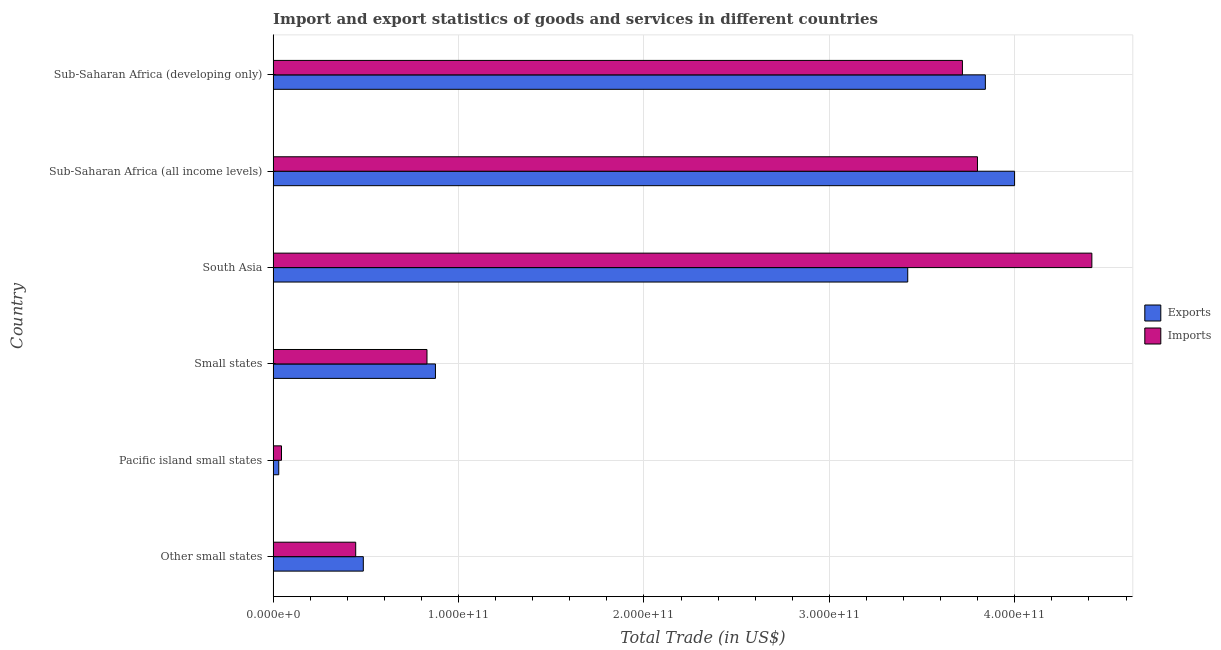How many different coloured bars are there?
Offer a very short reply. 2. How many groups of bars are there?
Make the answer very short. 6. Are the number of bars on each tick of the Y-axis equal?
Keep it short and to the point. Yes. How many bars are there on the 3rd tick from the top?
Your answer should be very brief. 2. How many bars are there on the 6th tick from the bottom?
Make the answer very short. 2. What is the label of the 4th group of bars from the top?
Your response must be concise. Small states. What is the imports of goods and services in Sub-Saharan Africa (all income levels)?
Your answer should be compact. 3.80e+11. Across all countries, what is the maximum imports of goods and services?
Your answer should be very brief. 4.42e+11. Across all countries, what is the minimum export of goods and services?
Make the answer very short. 3.03e+09. In which country was the export of goods and services maximum?
Your answer should be compact. Sub-Saharan Africa (all income levels). In which country was the imports of goods and services minimum?
Provide a succinct answer. Pacific island small states. What is the total imports of goods and services in the graph?
Keep it short and to the point. 1.33e+12. What is the difference between the imports of goods and services in Small states and that in Sub-Saharan Africa (all income levels)?
Your response must be concise. -2.97e+11. What is the difference between the export of goods and services in South Asia and the imports of goods and services in Small states?
Offer a very short reply. 2.59e+11. What is the average imports of goods and services per country?
Ensure brevity in your answer.  2.21e+11. What is the difference between the imports of goods and services and export of goods and services in Small states?
Ensure brevity in your answer.  -4.56e+09. In how many countries, is the export of goods and services greater than 20000000000 US$?
Give a very brief answer. 5. What is the ratio of the imports of goods and services in Other small states to that in Sub-Saharan Africa (all income levels)?
Your answer should be very brief. 0.12. Is the imports of goods and services in Small states less than that in South Asia?
Give a very brief answer. Yes. What is the difference between the highest and the second highest imports of goods and services?
Your answer should be very brief. 6.17e+1. What is the difference between the highest and the lowest imports of goods and services?
Ensure brevity in your answer.  4.37e+11. Is the sum of the imports of goods and services in Pacific island small states and Sub-Saharan Africa (all income levels) greater than the maximum export of goods and services across all countries?
Offer a very short reply. No. What does the 1st bar from the top in Other small states represents?
Your response must be concise. Imports. What does the 2nd bar from the bottom in Sub-Saharan Africa (developing only) represents?
Your response must be concise. Imports. What is the difference between two consecutive major ticks on the X-axis?
Ensure brevity in your answer.  1.00e+11. Are the values on the major ticks of X-axis written in scientific E-notation?
Offer a terse response. Yes. Does the graph contain any zero values?
Your answer should be very brief. No. How many legend labels are there?
Your answer should be compact. 2. How are the legend labels stacked?
Your response must be concise. Vertical. What is the title of the graph?
Give a very brief answer. Import and export statistics of goods and services in different countries. What is the label or title of the X-axis?
Your response must be concise. Total Trade (in US$). What is the Total Trade (in US$) of Exports in Other small states?
Your response must be concise. 4.86e+1. What is the Total Trade (in US$) of Imports in Other small states?
Ensure brevity in your answer.  4.45e+1. What is the Total Trade (in US$) of Exports in Pacific island small states?
Provide a short and direct response. 3.03e+09. What is the Total Trade (in US$) in Imports in Pacific island small states?
Ensure brevity in your answer.  4.52e+09. What is the Total Trade (in US$) of Exports in Small states?
Your response must be concise. 8.75e+1. What is the Total Trade (in US$) in Imports in Small states?
Offer a very short reply. 8.30e+1. What is the Total Trade (in US$) of Exports in South Asia?
Offer a terse response. 3.42e+11. What is the Total Trade (in US$) of Imports in South Asia?
Provide a short and direct response. 4.42e+11. What is the Total Trade (in US$) in Exports in Sub-Saharan Africa (all income levels)?
Keep it short and to the point. 4.00e+11. What is the Total Trade (in US$) in Imports in Sub-Saharan Africa (all income levels)?
Offer a very short reply. 3.80e+11. What is the Total Trade (in US$) of Exports in Sub-Saharan Africa (developing only)?
Ensure brevity in your answer.  3.84e+11. What is the Total Trade (in US$) in Imports in Sub-Saharan Africa (developing only)?
Keep it short and to the point. 3.72e+11. Across all countries, what is the maximum Total Trade (in US$) in Exports?
Offer a terse response. 4.00e+11. Across all countries, what is the maximum Total Trade (in US$) in Imports?
Make the answer very short. 4.42e+11. Across all countries, what is the minimum Total Trade (in US$) in Exports?
Your response must be concise. 3.03e+09. Across all countries, what is the minimum Total Trade (in US$) in Imports?
Ensure brevity in your answer.  4.52e+09. What is the total Total Trade (in US$) in Exports in the graph?
Provide a short and direct response. 1.27e+12. What is the total Total Trade (in US$) of Imports in the graph?
Offer a terse response. 1.33e+12. What is the difference between the Total Trade (in US$) in Exports in Other small states and that in Pacific island small states?
Offer a terse response. 4.56e+1. What is the difference between the Total Trade (in US$) of Imports in Other small states and that in Pacific island small states?
Offer a terse response. 4.00e+1. What is the difference between the Total Trade (in US$) of Exports in Other small states and that in Small states?
Ensure brevity in your answer.  -3.89e+1. What is the difference between the Total Trade (in US$) in Imports in Other small states and that in Small states?
Offer a very short reply. -3.84e+1. What is the difference between the Total Trade (in US$) in Exports in Other small states and that in South Asia?
Your answer should be very brief. -2.94e+11. What is the difference between the Total Trade (in US$) in Imports in Other small states and that in South Asia?
Make the answer very short. -3.97e+11. What is the difference between the Total Trade (in US$) in Exports in Other small states and that in Sub-Saharan Africa (all income levels)?
Your answer should be very brief. -3.51e+11. What is the difference between the Total Trade (in US$) in Imports in Other small states and that in Sub-Saharan Africa (all income levels)?
Your answer should be compact. -3.35e+11. What is the difference between the Total Trade (in US$) of Exports in Other small states and that in Sub-Saharan Africa (developing only)?
Your answer should be compact. -3.35e+11. What is the difference between the Total Trade (in US$) in Imports in Other small states and that in Sub-Saharan Africa (developing only)?
Provide a short and direct response. -3.27e+11. What is the difference between the Total Trade (in US$) of Exports in Pacific island small states and that in Small states?
Your answer should be compact. -8.45e+1. What is the difference between the Total Trade (in US$) of Imports in Pacific island small states and that in Small states?
Offer a terse response. -7.85e+1. What is the difference between the Total Trade (in US$) in Exports in Pacific island small states and that in South Asia?
Your answer should be compact. -3.39e+11. What is the difference between the Total Trade (in US$) of Imports in Pacific island small states and that in South Asia?
Provide a short and direct response. -4.37e+11. What is the difference between the Total Trade (in US$) in Exports in Pacific island small states and that in Sub-Saharan Africa (all income levels)?
Your answer should be very brief. -3.97e+11. What is the difference between the Total Trade (in US$) of Imports in Pacific island small states and that in Sub-Saharan Africa (all income levels)?
Make the answer very short. -3.75e+11. What is the difference between the Total Trade (in US$) of Exports in Pacific island small states and that in Sub-Saharan Africa (developing only)?
Offer a very short reply. -3.81e+11. What is the difference between the Total Trade (in US$) of Imports in Pacific island small states and that in Sub-Saharan Africa (developing only)?
Offer a very short reply. -3.67e+11. What is the difference between the Total Trade (in US$) in Exports in Small states and that in South Asia?
Provide a succinct answer. -2.55e+11. What is the difference between the Total Trade (in US$) in Imports in Small states and that in South Asia?
Provide a short and direct response. -3.59e+11. What is the difference between the Total Trade (in US$) of Exports in Small states and that in Sub-Saharan Africa (all income levels)?
Your response must be concise. -3.12e+11. What is the difference between the Total Trade (in US$) in Imports in Small states and that in Sub-Saharan Africa (all income levels)?
Offer a terse response. -2.97e+11. What is the difference between the Total Trade (in US$) in Exports in Small states and that in Sub-Saharan Africa (developing only)?
Give a very brief answer. -2.97e+11. What is the difference between the Total Trade (in US$) in Imports in Small states and that in Sub-Saharan Africa (developing only)?
Provide a short and direct response. -2.89e+11. What is the difference between the Total Trade (in US$) of Exports in South Asia and that in Sub-Saharan Africa (all income levels)?
Your answer should be very brief. -5.76e+1. What is the difference between the Total Trade (in US$) in Imports in South Asia and that in Sub-Saharan Africa (all income levels)?
Your answer should be compact. 6.17e+1. What is the difference between the Total Trade (in US$) of Exports in South Asia and that in Sub-Saharan Africa (developing only)?
Your response must be concise. -4.19e+1. What is the difference between the Total Trade (in US$) of Imports in South Asia and that in Sub-Saharan Africa (developing only)?
Make the answer very short. 6.98e+1. What is the difference between the Total Trade (in US$) of Exports in Sub-Saharan Africa (all income levels) and that in Sub-Saharan Africa (developing only)?
Provide a short and direct response. 1.58e+1. What is the difference between the Total Trade (in US$) of Imports in Sub-Saharan Africa (all income levels) and that in Sub-Saharan Africa (developing only)?
Provide a short and direct response. 8.11e+09. What is the difference between the Total Trade (in US$) in Exports in Other small states and the Total Trade (in US$) in Imports in Pacific island small states?
Offer a terse response. 4.41e+1. What is the difference between the Total Trade (in US$) of Exports in Other small states and the Total Trade (in US$) of Imports in Small states?
Offer a terse response. -3.43e+1. What is the difference between the Total Trade (in US$) of Exports in Other small states and the Total Trade (in US$) of Imports in South Asia?
Offer a terse response. -3.93e+11. What is the difference between the Total Trade (in US$) in Exports in Other small states and the Total Trade (in US$) in Imports in Sub-Saharan Africa (all income levels)?
Ensure brevity in your answer.  -3.31e+11. What is the difference between the Total Trade (in US$) in Exports in Other small states and the Total Trade (in US$) in Imports in Sub-Saharan Africa (developing only)?
Your response must be concise. -3.23e+11. What is the difference between the Total Trade (in US$) in Exports in Pacific island small states and the Total Trade (in US$) in Imports in Small states?
Provide a succinct answer. -7.99e+1. What is the difference between the Total Trade (in US$) in Exports in Pacific island small states and the Total Trade (in US$) in Imports in South Asia?
Provide a short and direct response. -4.39e+11. What is the difference between the Total Trade (in US$) in Exports in Pacific island small states and the Total Trade (in US$) in Imports in Sub-Saharan Africa (all income levels)?
Provide a short and direct response. -3.77e+11. What is the difference between the Total Trade (in US$) of Exports in Pacific island small states and the Total Trade (in US$) of Imports in Sub-Saharan Africa (developing only)?
Make the answer very short. -3.69e+11. What is the difference between the Total Trade (in US$) in Exports in Small states and the Total Trade (in US$) in Imports in South Asia?
Your response must be concise. -3.54e+11. What is the difference between the Total Trade (in US$) in Exports in Small states and the Total Trade (in US$) in Imports in Sub-Saharan Africa (all income levels)?
Offer a very short reply. -2.92e+11. What is the difference between the Total Trade (in US$) in Exports in Small states and the Total Trade (in US$) in Imports in Sub-Saharan Africa (developing only)?
Ensure brevity in your answer.  -2.84e+11. What is the difference between the Total Trade (in US$) in Exports in South Asia and the Total Trade (in US$) in Imports in Sub-Saharan Africa (all income levels)?
Offer a very short reply. -3.76e+1. What is the difference between the Total Trade (in US$) of Exports in South Asia and the Total Trade (in US$) of Imports in Sub-Saharan Africa (developing only)?
Make the answer very short. -2.95e+1. What is the difference between the Total Trade (in US$) of Exports in Sub-Saharan Africa (all income levels) and the Total Trade (in US$) of Imports in Sub-Saharan Africa (developing only)?
Ensure brevity in your answer.  2.81e+1. What is the average Total Trade (in US$) of Exports per country?
Give a very brief answer. 2.11e+11. What is the average Total Trade (in US$) in Imports per country?
Provide a short and direct response. 2.21e+11. What is the difference between the Total Trade (in US$) of Exports and Total Trade (in US$) of Imports in Other small states?
Provide a succinct answer. 4.10e+09. What is the difference between the Total Trade (in US$) of Exports and Total Trade (in US$) of Imports in Pacific island small states?
Offer a terse response. -1.48e+09. What is the difference between the Total Trade (in US$) in Exports and Total Trade (in US$) in Imports in Small states?
Your answer should be compact. 4.56e+09. What is the difference between the Total Trade (in US$) in Exports and Total Trade (in US$) in Imports in South Asia?
Provide a succinct answer. -9.93e+1. What is the difference between the Total Trade (in US$) of Exports and Total Trade (in US$) of Imports in Sub-Saharan Africa (all income levels)?
Give a very brief answer. 2.00e+1. What is the difference between the Total Trade (in US$) of Exports and Total Trade (in US$) of Imports in Sub-Saharan Africa (developing only)?
Ensure brevity in your answer.  1.24e+1. What is the ratio of the Total Trade (in US$) in Exports in Other small states to that in Pacific island small states?
Offer a very short reply. 16.03. What is the ratio of the Total Trade (in US$) in Imports in Other small states to that in Pacific island small states?
Provide a short and direct response. 9.86. What is the ratio of the Total Trade (in US$) in Exports in Other small states to that in Small states?
Make the answer very short. 0.56. What is the ratio of the Total Trade (in US$) in Imports in Other small states to that in Small states?
Your answer should be compact. 0.54. What is the ratio of the Total Trade (in US$) in Exports in Other small states to that in South Asia?
Your answer should be very brief. 0.14. What is the ratio of the Total Trade (in US$) in Imports in Other small states to that in South Asia?
Make the answer very short. 0.1. What is the ratio of the Total Trade (in US$) in Exports in Other small states to that in Sub-Saharan Africa (all income levels)?
Keep it short and to the point. 0.12. What is the ratio of the Total Trade (in US$) of Imports in Other small states to that in Sub-Saharan Africa (all income levels)?
Keep it short and to the point. 0.12. What is the ratio of the Total Trade (in US$) of Exports in Other small states to that in Sub-Saharan Africa (developing only)?
Offer a very short reply. 0.13. What is the ratio of the Total Trade (in US$) of Imports in Other small states to that in Sub-Saharan Africa (developing only)?
Give a very brief answer. 0.12. What is the ratio of the Total Trade (in US$) of Exports in Pacific island small states to that in Small states?
Ensure brevity in your answer.  0.03. What is the ratio of the Total Trade (in US$) of Imports in Pacific island small states to that in Small states?
Give a very brief answer. 0.05. What is the ratio of the Total Trade (in US$) of Exports in Pacific island small states to that in South Asia?
Offer a terse response. 0.01. What is the ratio of the Total Trade (in US$) in Imports in Pacific island small states to that in South Asia?
Offer a very short reply. 0.01. What is the ratio of the Total Trade (in US$) in Exports in Pacific island small states to that in Sub-Saharan Africa (all income levels)?
Make the answer very short. 0.01. What is the ratio of the Total Trade (in US$) in Imports in Pacific island small states to that in Sub-Saharan Africa (all income levels)?
Offer a very short reply. 0.01. What is the ratio of the Total Trade (in US$) in Exports in Pacific island small states to that in Sub-Saharan Africa (developing only)?
Keep it short and to the point. 0.01. What is the ratio of the Total Trade (in US$) of Imports in Pacific island small states to that in Sub-Saharan Africa (developing only)?
Your answer should be very brief. 0.01. What is the ratio of the Total Trade (in US$) of Exports in Small states to that in South Asia?
Your response must be concise. 0.26. What is the ratio of the Total Trade (in US$) of Imports in Small states to that in South Asia?
Offer a terse response. 0.19. What is the ratio of the Total Trade (in US$) of Exports in Small states to that in Sub-Saharan Africa (all income levels)?
Offer a terse response. 0.22. What is the ratio of the Total Trade (in US$) in Imports in Small states to that in Sub-Saharan Africa (all income levels)?
Make the answer very short. 0.22. What is the ratio of the Total Trade (in US$) in Exports in Small states to that in Sub-Saharan Africa (developing only)?
Your answer should be compact. 0.23. What is the ratio of the Total Trade (in US$) of Imports in Small states to that in Sub-Saharan Africa (developing only)?
Keep it short and to the point. 0.22. What is the ratio of the Total Trade (in US$) in Exports in South Asia to that in Sub-Saharan Africa (all income levels)?
Make the answer very short. 0.86. What is the ratio of the Total Trade (in US$) in Imports in South Asia to that in Sub-Saharan Africa (all income levels)?
Keep it short and to the point. 1.16. What is the ratio of the Total Trade (in US$) in Exports in South Asia to that in Sub-Saharan Africa (developing only)?
Keep it short and to the point. 0.89. What is the ratio of the Total Trade (in US$) in Imports in South Asia to that in Sub-Saharan Africa (developing only)?
Offer a very short reply. 1.19. What is the ratio of the Total Trade (in US$) in Exports in Sub-Saharan Africa (all income levels) to that in Sub-Saharan Africa (developing only)?
Make the answer very short. 1.04. What is the ratio of the Total Trade (in US$) of Imports in Sub-Saharan Africa (all income levels) to that in Sub-Saharan Africa (developing only)?
Your answer should be compact. 1.02. What is the difference between the highest and the second highest Total Trade (in US$) in Exports?
Give a very brief answer. 1.58e+1. What is the difference between the highest and the second highest Total Trade (in US$) of Imports?
Offer a terse response. 6.17e+1. What is the difference between the highest and the lowest Total Trade (in US$) in Exports?
Provide a short and direct response. 3.97e+11. What is the difference between the highest and the lowest Total Trade (in US$) of Imports?
Provide a short and direct response. 4.37e+11. 